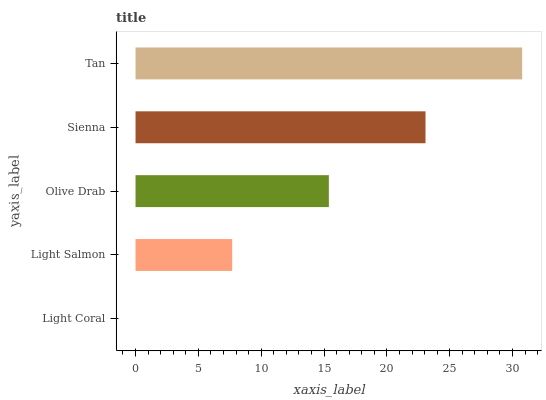Is Light Coral the minimum?
Answer yes or no. Yes. Is Tan the maximum?
Answer yes or no. Yes. Is Light Salmon the minimum?
Answer yes or no. No. Is Light Salmon the maximum?
Answer yes or no. No. Is Light Salmon greater than Light Coral?
Answer yes or no. Yes. Is Light Coral less than Light Salmon?
Answer yes or no. Yes. Is Light Coral greater than Light Salmon?
Answer yes or no. No. Is Light Salmon less than Light Coral?
Answer yes or no. No. Is Olive Drab the high median?
Answer yes or no. Yes. Is Olive Drab the low median?
Answer yes or no. Yes. Is Light Salmon the high median?
Answer yes or no. No. Is Light Coral the low median?
Answer yes or no. No. 